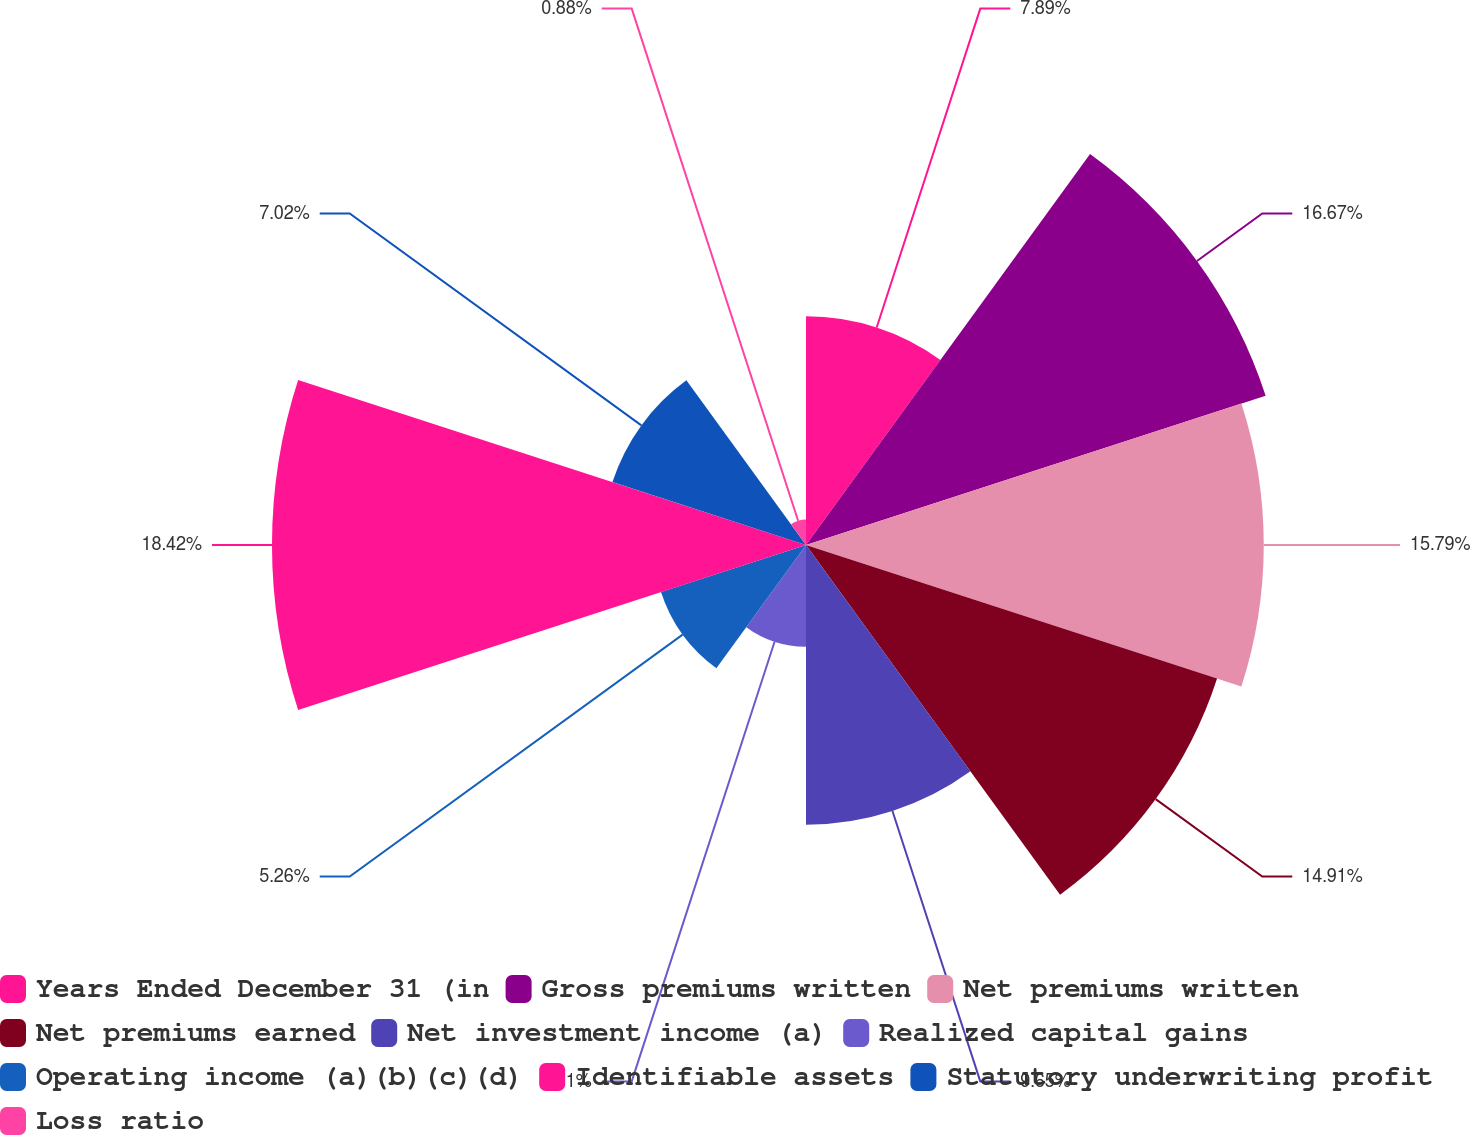<chart> <loc_0><loc_0><loc_500><loc_500><pie_chart><fcel>Years Ended December 31 (in<fcel>Gross premiums written<fcel>Net premiums written<fcel>Net premiums earned<fcel>Net investment income (a)<fcel>Realized capital gains<fcel>Operating income (a)(b)(c)(d)<fcel>Identifiable assets<fcel>Statutory underwriting profit<fcel>Loss ratio<nl><fcel>7.89%<fcel>16.67%<fcel>15.79%<fcel>14.91%<fcel>9.65%<fcel>3.51%<fcel>5.26%<fcel>18.42%<fcel>7.02%<fcel>0.88%<nl></chart> 